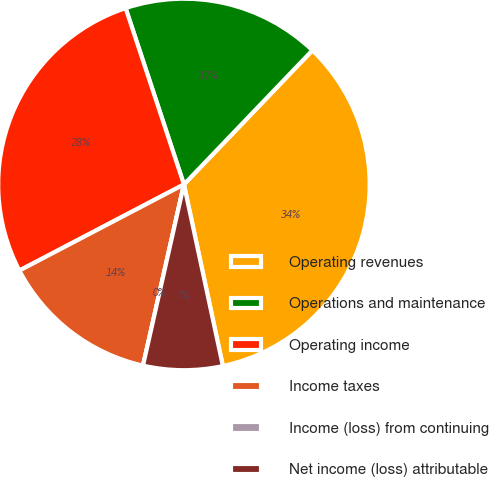Convert chart. <chart><loc_0><loc_0><loc_500><loc_500><pie_chart><fcel>Operating revenues<fcel>Operations and maintenance<fcel>Operating income<fcel>Income taxes<fcel>Income (loss) from continuing<fcel>Net income (loss) attributable<nl><fcel>34.48%<fcel>17.24%<fcel>27.59%<fcel>13.79%<fcel>0.0%<fcel>6.9%<nl></chart> 